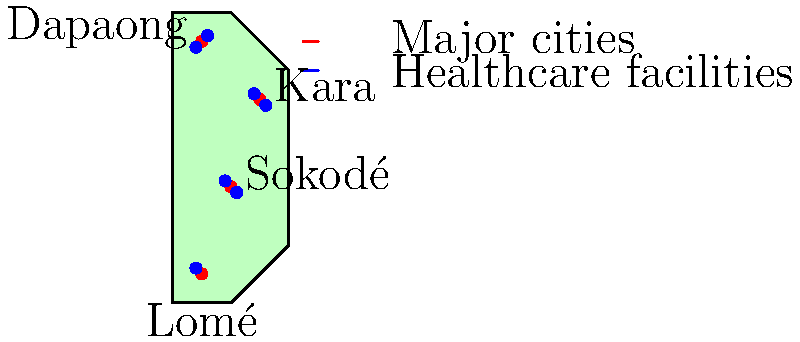Based on the map of Togo showing major cities (red dots) and healthcare facilities (blue dots), what is the main issue with the distribution of healthcare facilities that needs to be addressed to improve living standards? To analyze the distribution of healthcare facilities in Togo, we need to consider the following steps:

1. Observe the location of major cities:
   - Lomé in the south
   - Sokodé in the central region
   - Kara in the north
   - Dapaong in the far north

2. Examine the distribution of healthcare facilities:
   - Two facilities near Lomé
   - Two facilities near Sokodé
   - Two facilities near Kara
   - One facility near Dapaong

3. Analyze the pattern:
   - Healthcare facilities are clustered around major cities
   - There is a decreasing number of facilities as we move northward
   - The northern regions, especially around Dapaong, have fewer facilities

4. Consider population distribution:
   - Although not shown on the map, we can assume that population density varies across the country

5. Identify the main issue:
   - The primary problem is the uneven distribution of healthcare facilities
   - There is a concentration of facilities in the south and central regions
   - The northern areas, particularly around Dapaong, are underserved

6. Implications for living standards:
   - People in northern regions have less access to healthcare
   - This disparity can lead to poorer health outcomes and lower living standards in those areas

The main issue that needs to be addressed is the uneven distribution of healthcare facilities, with a focus on increasing access in the northern regions of Togo.
Answer: Uneven distribution with limited access in northern regions 